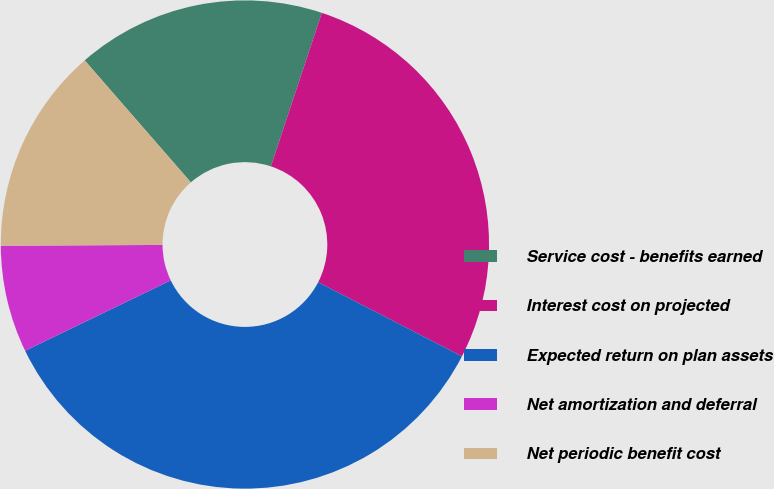Convert chart to OTSL. <chart><loc_0><loc_0><loc_500><loc_500><pie_chart><fcel>Service cost - benefits earned<fcel>Interest cost on projected<fcel>Expected return on plan assets<fcel>Net amortization and deferral<fcel>Net periodic benefit cost<nl><fcel>16.5%<fcel>27.47%<fcel>35.26%<fcel>7.09%<fcel>13.68%<nl></chart> 